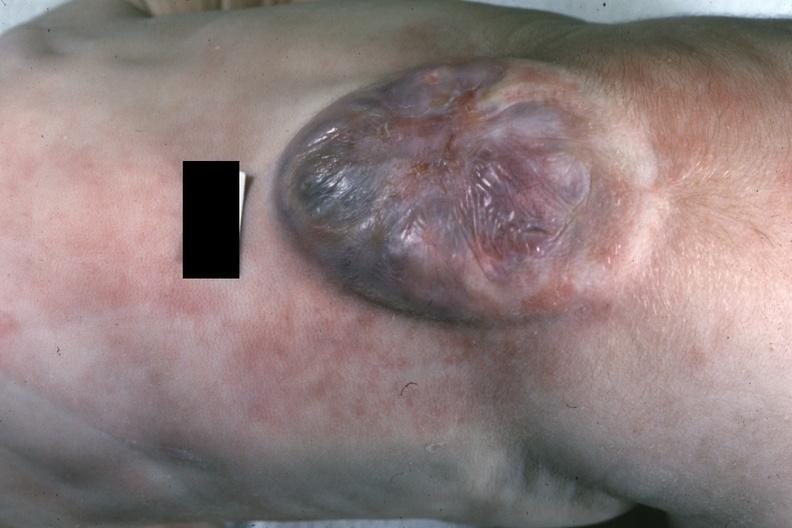does stillborn macerated show close-up excellent example?
Answer the question using a single word or phrase. No 